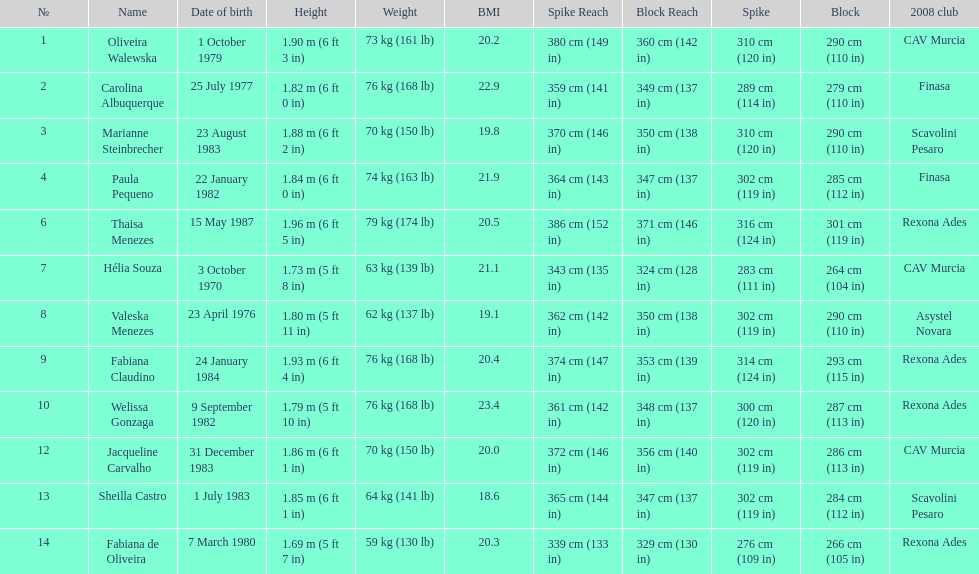Which player is the shortest at only 5 ft 7 in? Fabiana de Oliveira. 